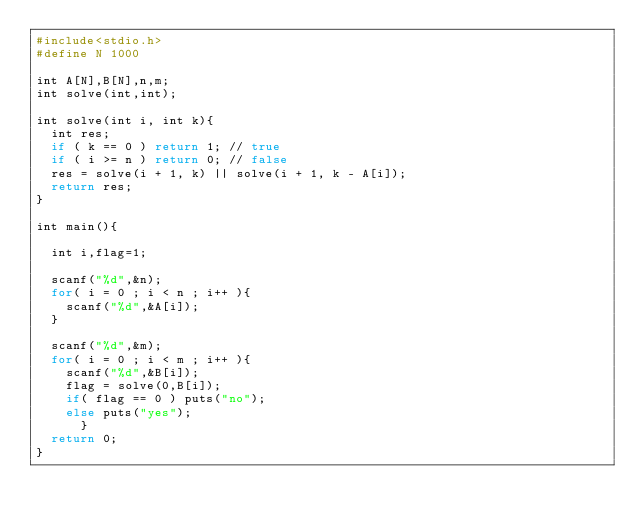<code> <loc_0><loc_0><loc_500><loc_500><_Ruby_>#include<stdio.h>
#define N 1000

int A[N],B[N],n,m;
int solve(int,int);

int solve(int i, int k){
  int res;
  if ( k == 0 ) return 1; // true
  if ( i >= n ) return 0; // false
  res = solve(i + 1, k) || solve(i + 1, k - A[i]);
  return res;
}

int main(){

  int i,flag=1;

  scanf("%d",&n);
  for( i = 0 ; i < n ; i++ ){
    scanf("%d",&A[i]);
  }

  scanf("%d",&m);
  for( i = 0 ; i < m ; i++ ){
    scanf("%d",&B[i]);
    flag = solve(0,B[i]);
    if( flag == 0 ) puts("no");
    else puts("yes");
      }
  return 0;
}</code> 